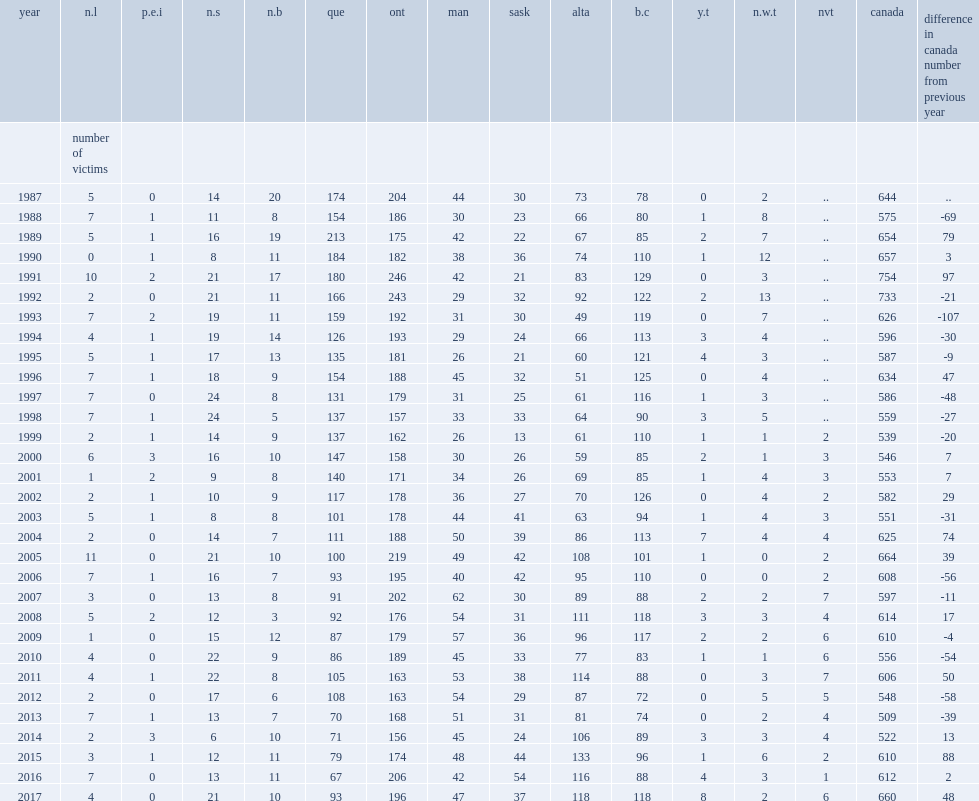In 2017, police reported 660 homicide victims in canada, what was the difference in 2016? 48.0. 